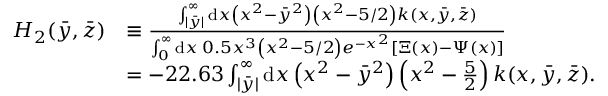<formula> <loc_0><loc_0><loc_500><loc_500>\begin{array} { r l } { H _ { 2 } ( \ B a r { y } , \ B a r { z } ) } & { \equiv \frac { \int _ { | \bar { y } | } ^ { \infty } d x \left ( x ^ { 2 } - \bar { y } ^ { 2 } \right ) \left ( x ^ { 2 } - 5 / 2 \right ) k ( x , \bar { y } , \bar { z } ) } { \int _ { 0 } ^ { \infty } d x \, 0 . 5 x ^ { 3 } \left ( x ^ { 2 } - 5 / 2 \right ) e ^ { - x ^ { 2 } } [ \Xi ( x ) - \Psi ( x ) ] } } \\ & { = - 2 2 . 6 3 \int _ { | \bar { y } | } ^ { \infty } d x \left ( x ^ { 2 } - \bar { y } ^ { 2 } \right ) \left ( x ^ { 2 } - \frac { 5 } { 2 } \right ) k ( x , \bar { y } , \bar { z } ) . } \end{array}</formula> 